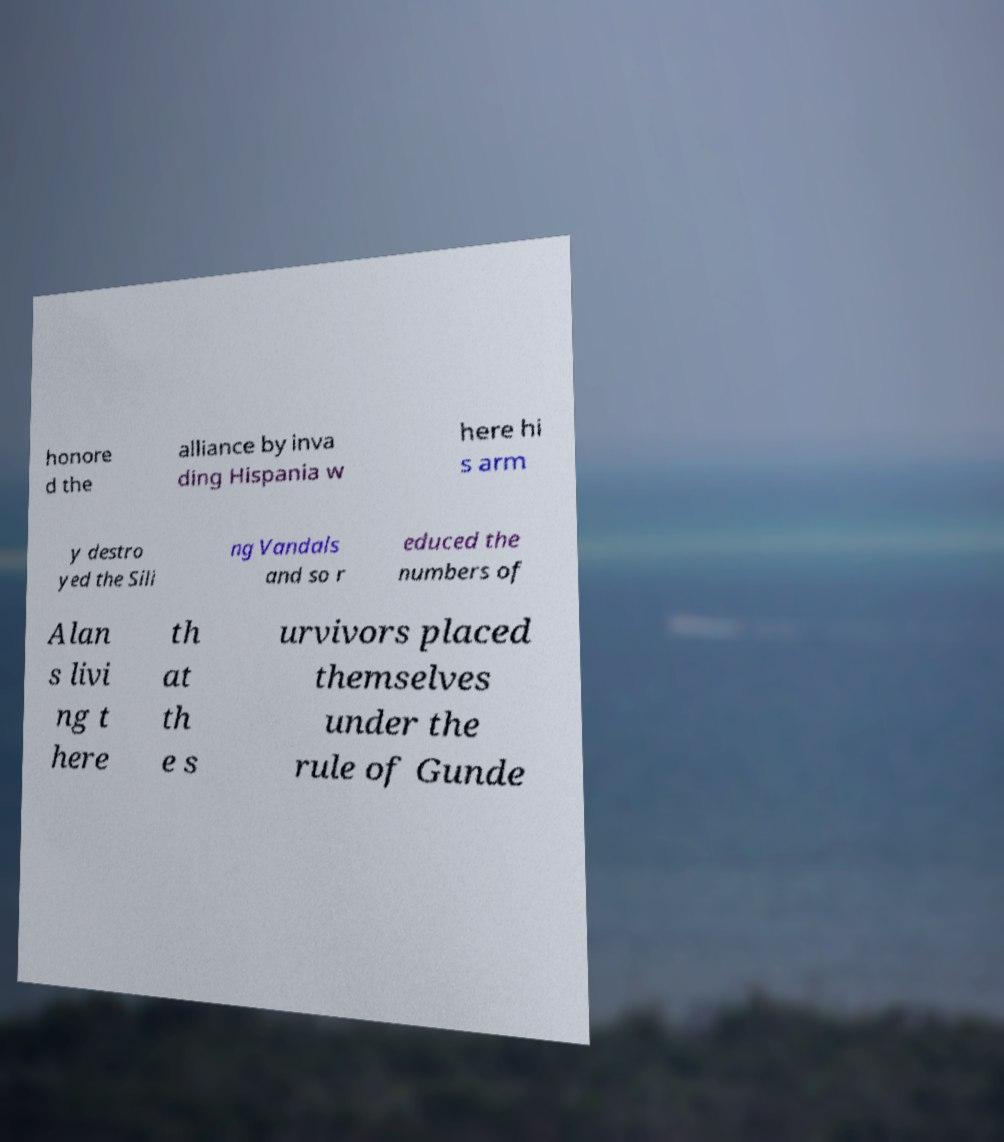Please identify and transcribe the text found in this image. honore d the alliance by inva ding Hispania w here hi s arm y destro yed the Sili ng Vandals and so r educed the numbers of Alan s livi ng t here th at th e s urvivors placed themselves under the rule of Gunde 